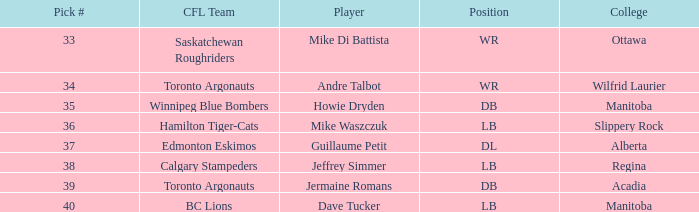What College has a Player that is jermaine romans? Acadia. 